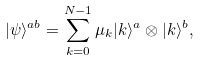<formula> <loc_0><loc_0><loc_500><loc_500>| \psi \rangle ^ { a b } = \sum _ { k = 0 } ^ { N - 1 } \mu _ { k } | k \rangle ^ { a } \otimes | k \rangle ^ { b } ,</formula> 